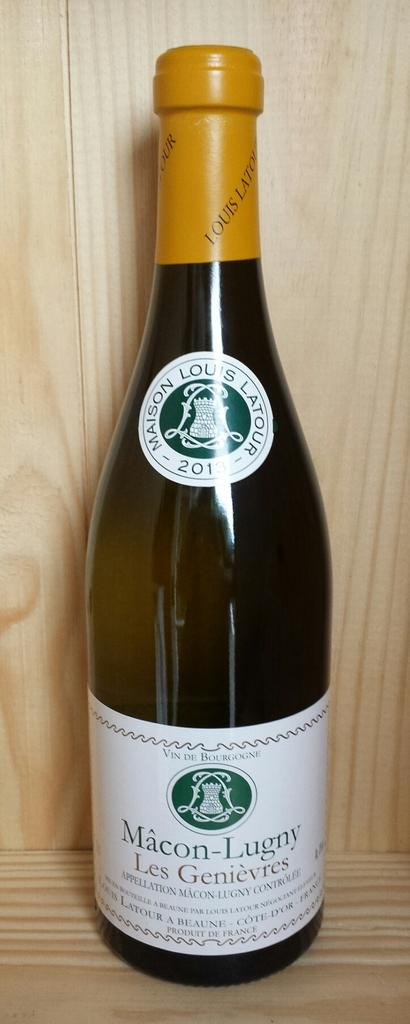<image>
Share a concise interpretation of the image provided. A bottle of Macon-Lugny sits on a wooden surface. 